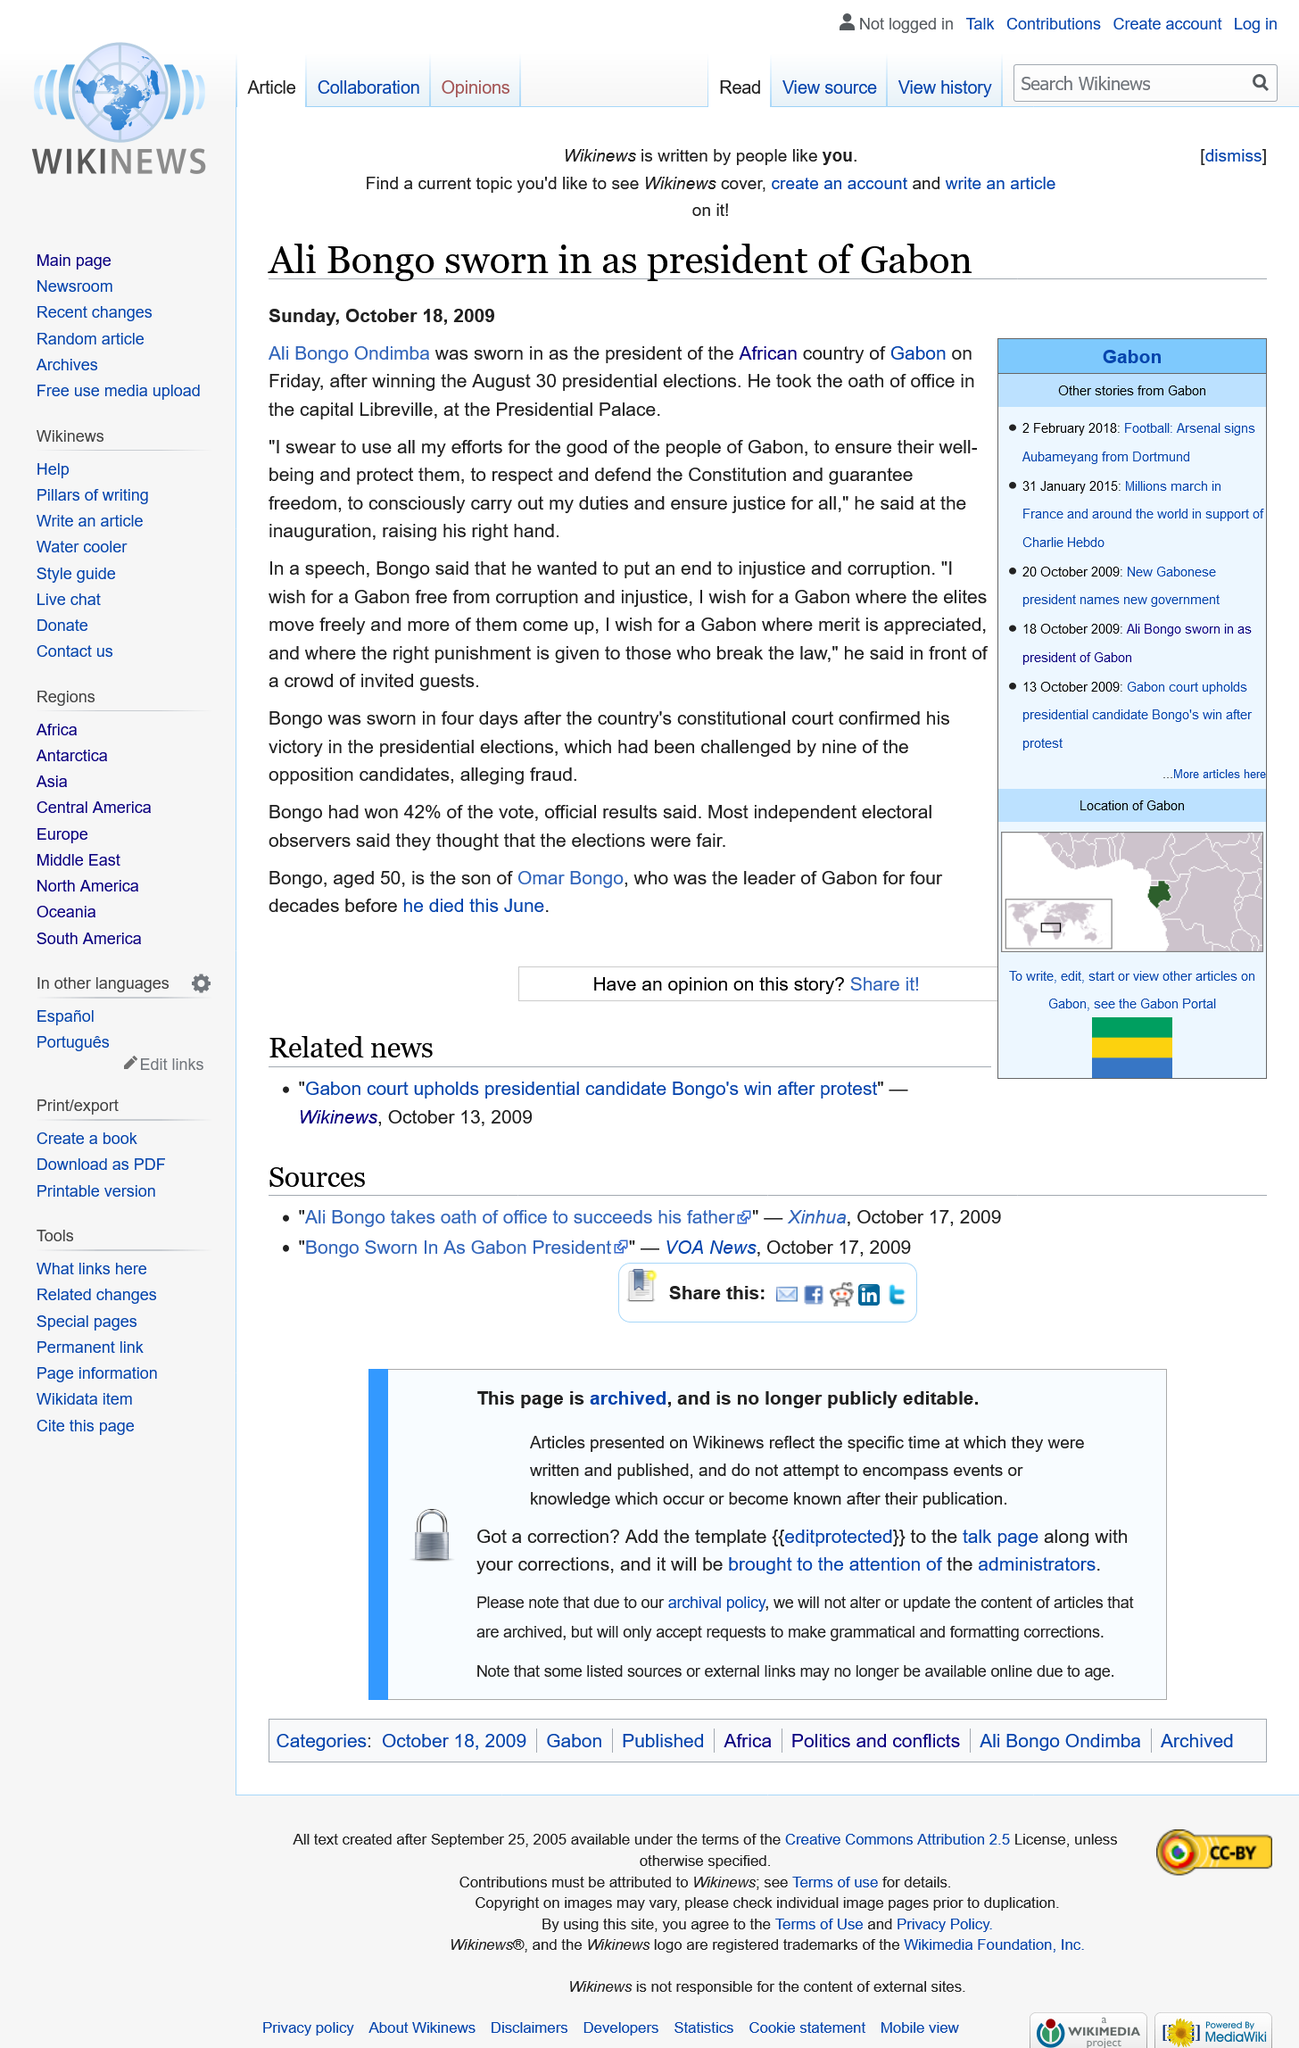Give some essential details in this illustration. The Gabon presidential elections were held on August 30, 2009. Ali Bongo Ondimba was sworn in as the President of Gabon on January 27, 2009. The speech took place in the capital of Libreville, at the Presidential Palace, in front of invited guests. 